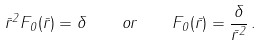Convert formula to latex. <formula><loc_0><loc_0><loc_500><loc_500>\bar { r } ^ { 2 } F _ { 0 } ( \bar { r } ) = \delta \quad o r \quad F _ { 0 } ( \bar { r } ) = \frac { \delta } { \bar { r } ^ { 2 } } \, .</formula> 